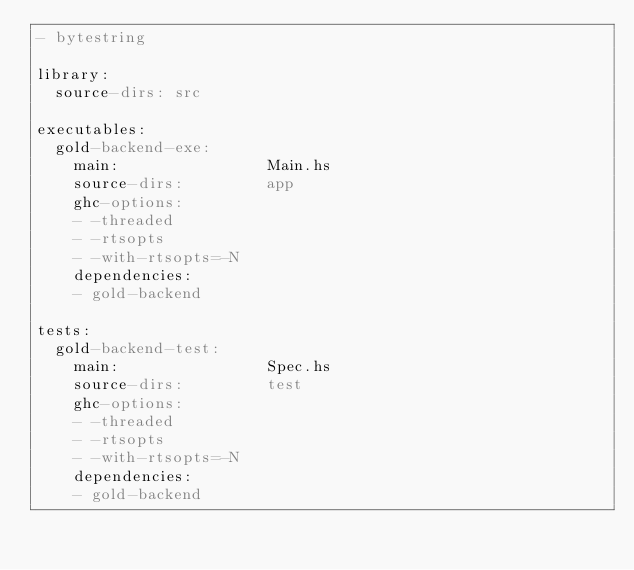<code> <loc_0><loc_0><loc_500><loc_500><_YAML_>- bytestring
 
library:
  source-dirs: src

executables:
  gold-backend-exe:
    main:                Main.hs
    source-dirs:         app
    ghc-options:
    - -threaded
    - -rtsopts
    - -with-rtsopts=-N
    dependencies:
    - gold-backend

tests:
  gold-backend-test:
    main:                Spec.hs
    source-dirs:         test
    ghc-options:
    - -threaded
    - -rtsopts
    - -with-rtsopts=-N
    dependencies:
    - gold-backend
</code> 